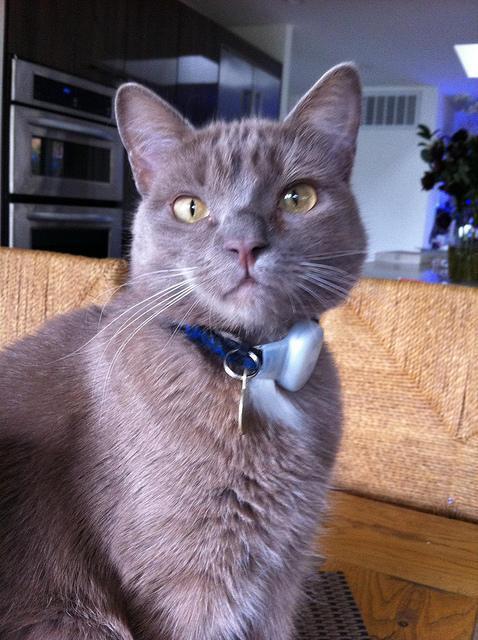How many giraffe are standing near the building?
Give a very brief answer. 0. 